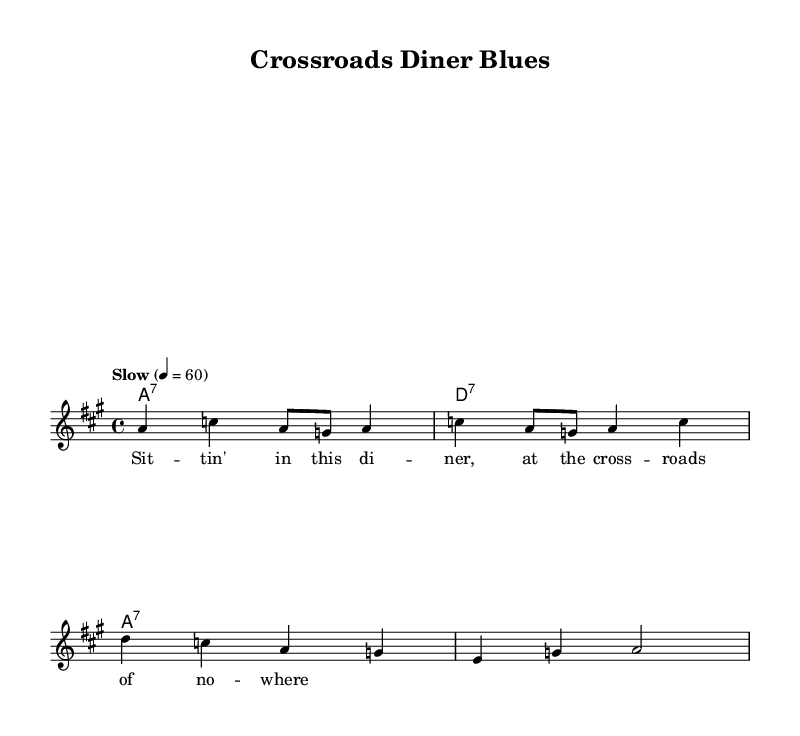What is the key signature of this music? The key signature is A major, which contains three sharps (F#, C#, and G#). This can be determined by looking at the key indication at the beginning of the score.
Answer: A major What is the time signature of this piece? The time signature can be found at the beginning of the score, noted next to the key signature. It is 4/4, meaning there are four beats in each measure and a quarter note gets one beat.
Answer: 4/4 What is the tempo marking for this piece? The tempo is indicated in the score, which specifies "Slow" with a metronome marking of 60 beats per minute. This indicates a slow, steady pace for the performance.
Answer: Slow How many measures are there in the melody? By counting the number of distinct rhythmic groupings or sections in the melody line provided, there are four measures in total.
Answer: 4 Which chord repeats the most in the harmonies? In the harmony section, the chord A7 appears in each measure for the three measures presented, which indicates its prominence in the piece.
Answer: A7 What is the title of the composition? The title can be found in the header section of the score, which indicates the name of the piece, "Crossroads Diner Blues."
Answer: Crossroads Diner Blues What type of song is this piece an example of? Based on the title and the style of the sheet music, this piece exemplifies a Blues ballad, which is characterized by its narrative lyrics and emotive structures.
Answer: Blues ballad 